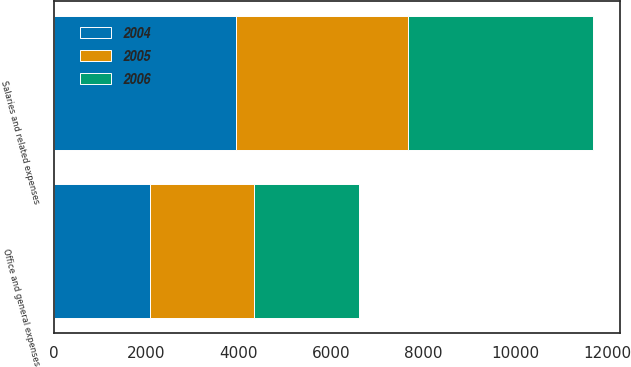Convert chart. <chart><loc_0><loc_0><loc_500><loc_500><stacked_bar_chart><ecel><fcel>Salaries and related expenses<fcel>Office and general expenses<nl><fcel>2004<fcel>3944.1<fcel>2079<nl><fcel>2006<fcel>3999.1<fcel>2288.1<nl><fcel>2005<fcel>3733<fcel>2250.4<nl></chart> 